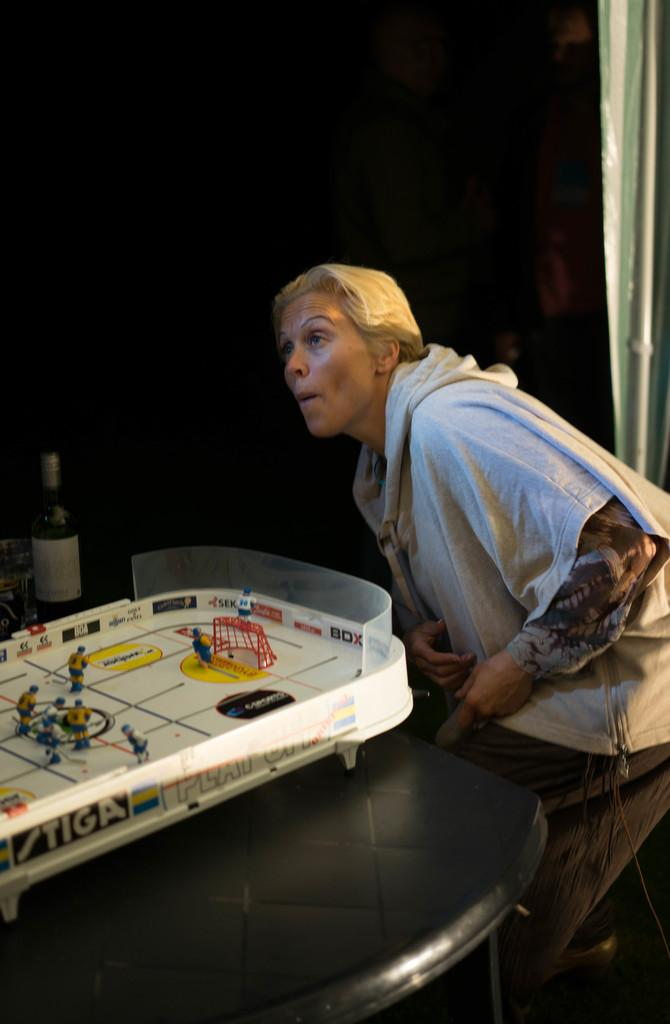Who is the main subject in the image? There is a woman in the image. What is the woman wearing? The woman is wearing a white hoodie. What is the woman doing in the image? The woman is bending over a table. What can be seen on the table in the image? There is a toy playing a football game and a wine bottle on the table. What type of nest can be seen in the image? There is no nest present in the image. How does the toy turn during the football game in the image? The image does not show the toy turning during the football game; it only shows the toy playing the game. 